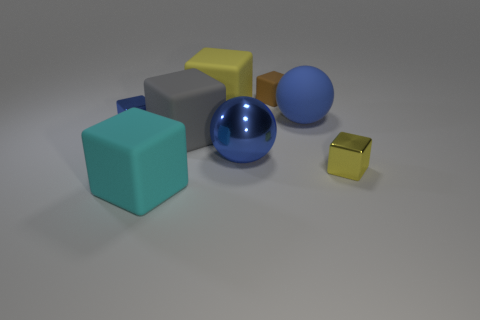Subtract all tiny metallic blocks. How many blocks are left? 4 Subtract all purple cylinders. How many yellow blocks are left? 2 Subtract all cyan cubes. How many cubes are left? 5 Add 1 big blue rubber balls. How many objects exist? 9 Subtract all spheres. How many objects are left? 6 Subtract all cyan blocks. Subtract all cyan cylinders. How many blocks are left? 5 Subtract all big cyan spheres. Subtract all matte cubes. How many objects are left? 4 Add 4 yellow metal things. How many yellow metal things are left? 5 Add 7 small matte things. How many small matte things exist? 8 Subtract 1 gray blocks. How many objects are left? 7 